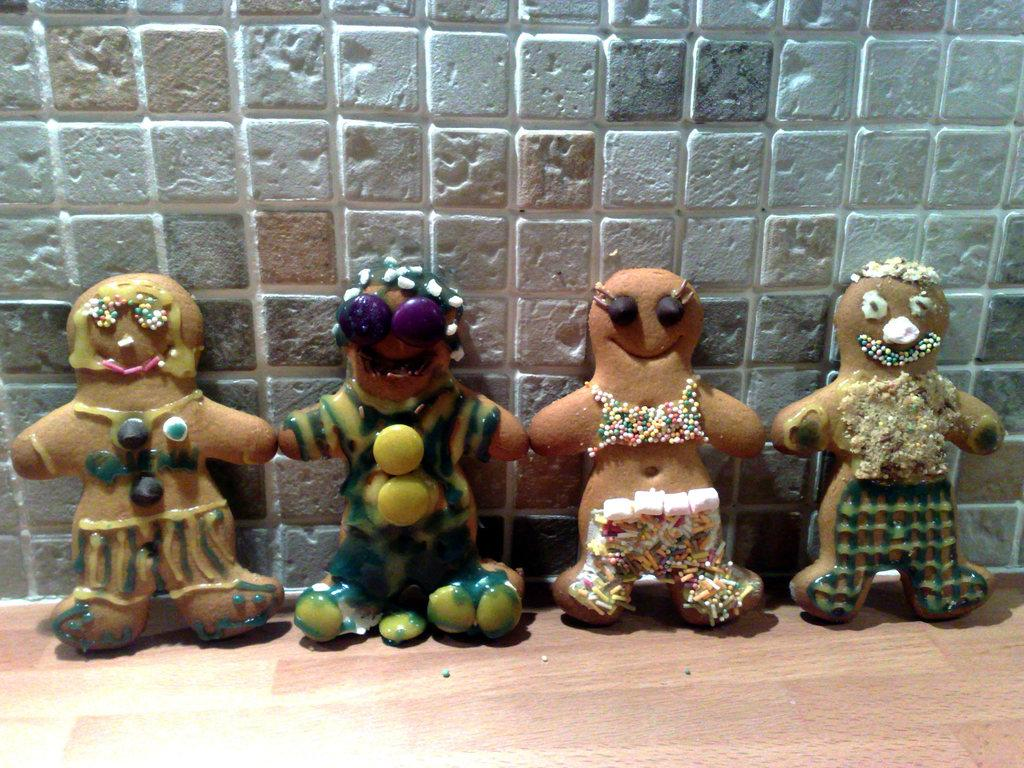How many dolls are present in the image? There are four dolls in the image. What distinguishes each doll from the others? Each doll has different things on them. Are the dolls playing a game of chess in the image? There is no indication of a chess game or any game being played in the image; it simply shows four dolls with different things on them. 